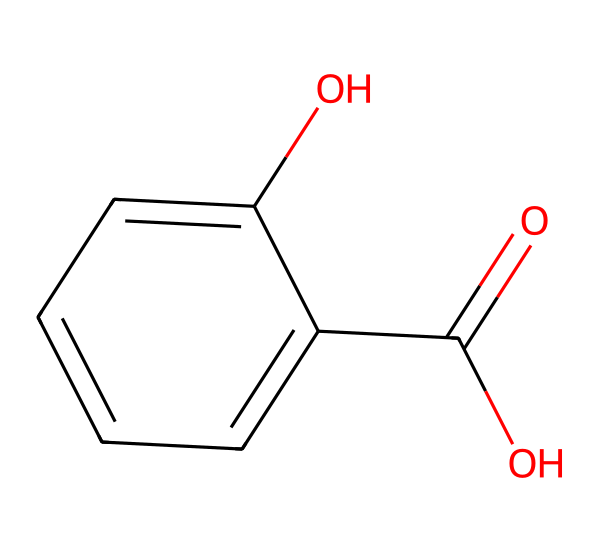what is the molecular formula of salicylic acid? The molecular formula can be derived by counting the number of each type of atom in the structure represented by the SMILES. In the SMILES notation, there are 7 carbon (C) atoms, 6 hydrogen (H) atoms, and 3 oxygen (O) atoms. Therefore, the molecular formula is C7H6O3.
Answer: C7H6O3 how many hydroxyl groups are present in salicylic acid? In the structural representation, a hydroxyl group (-OH) is indicated by the presence of an oxygen atom bonded to a hydrogen atom. The SMILES notation shows one hydroxyl group on the benzene ring, and another one is part of the carboxylic acid group. Thus, there are 2 hydroxyl groups.
Answer: 2 what type of acid is salicylic acid? Salicylic acid is classified as a carboxylic acid due to the presence of a carboxyl group (-COOH) within its structure. This is evident from the drawn structure derived from the SMILES, emphasizing the acidic nature of this compound.
Answer: carboxylic how many double bonds are present in salicylic acid? The presence of double bonds in the structure can be determined by inspecting the connections in the SMILES notation. There is one double bond between the carbon of the carboxylic group and an oxygen atom, and there is additionally one double bond in the phenolic structure. Thus, there are 2 double bonds in the entire molecule.
Answer: 2 what is the functional group of salicylic acid? The functional groups in the molecule can be identified from the structure. Salicylic acid contains a carboxylic acid functional group (-COOH) and a hydroxyl functional group (-OH), which are crucial for its reactivity and properties. Thus, the primary functional group is the carboxylic acid.
Answer: carboxylic acid 